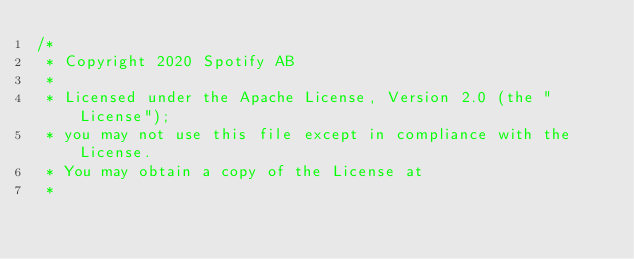Convert code to text. <code><loc_0><loc_0><loc_500><loc_500><_TypeScript_>/*
 * Copyright 2020 Spotify AB
 *
 * Licensed under the Apache License, Version 2.0 (the "License");
 * you may not use this file except in compliance with the License.
 * You may obtain a copy of the License at
 *</code> 